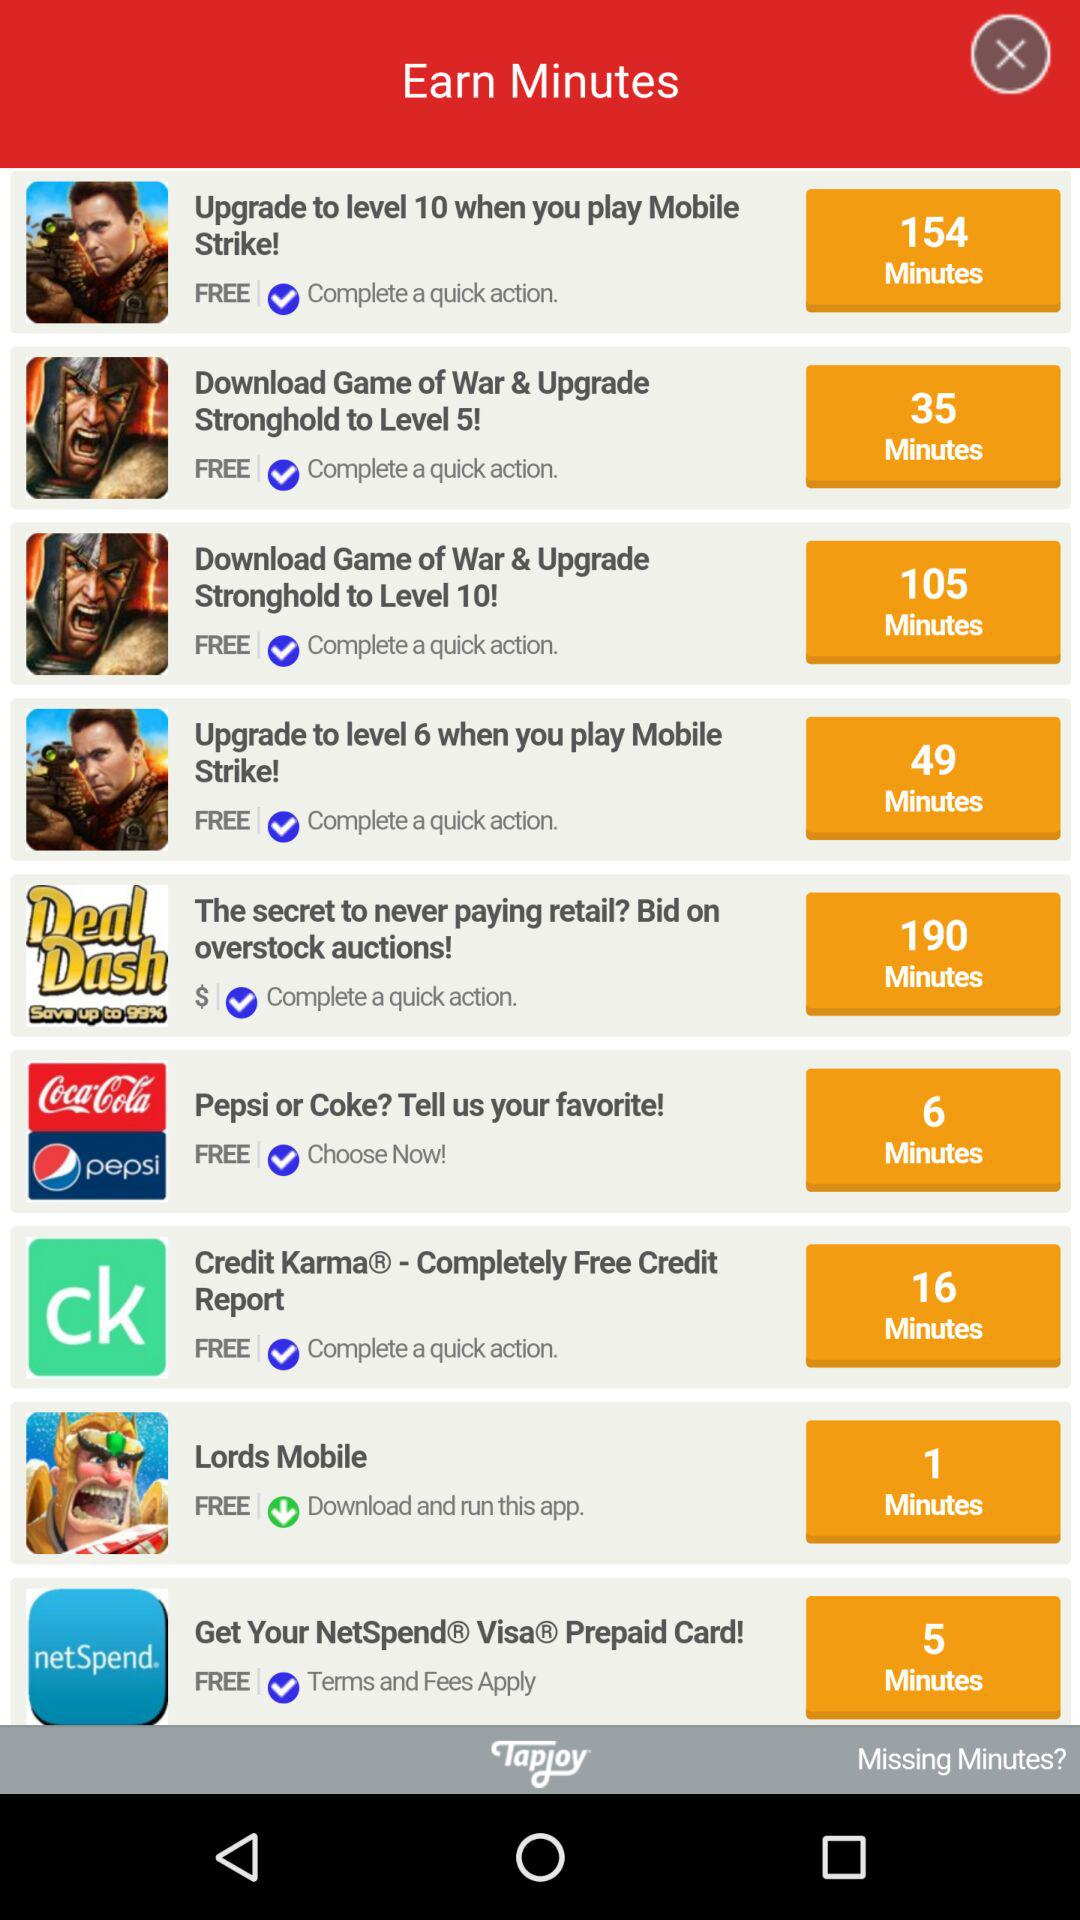How many minutes can be earned from "Pepsi or Coke? Tell us your favorite!"? The number of minutes that can be earned from "Pepsi or Coke? Tell us your favorite!" is 6. 